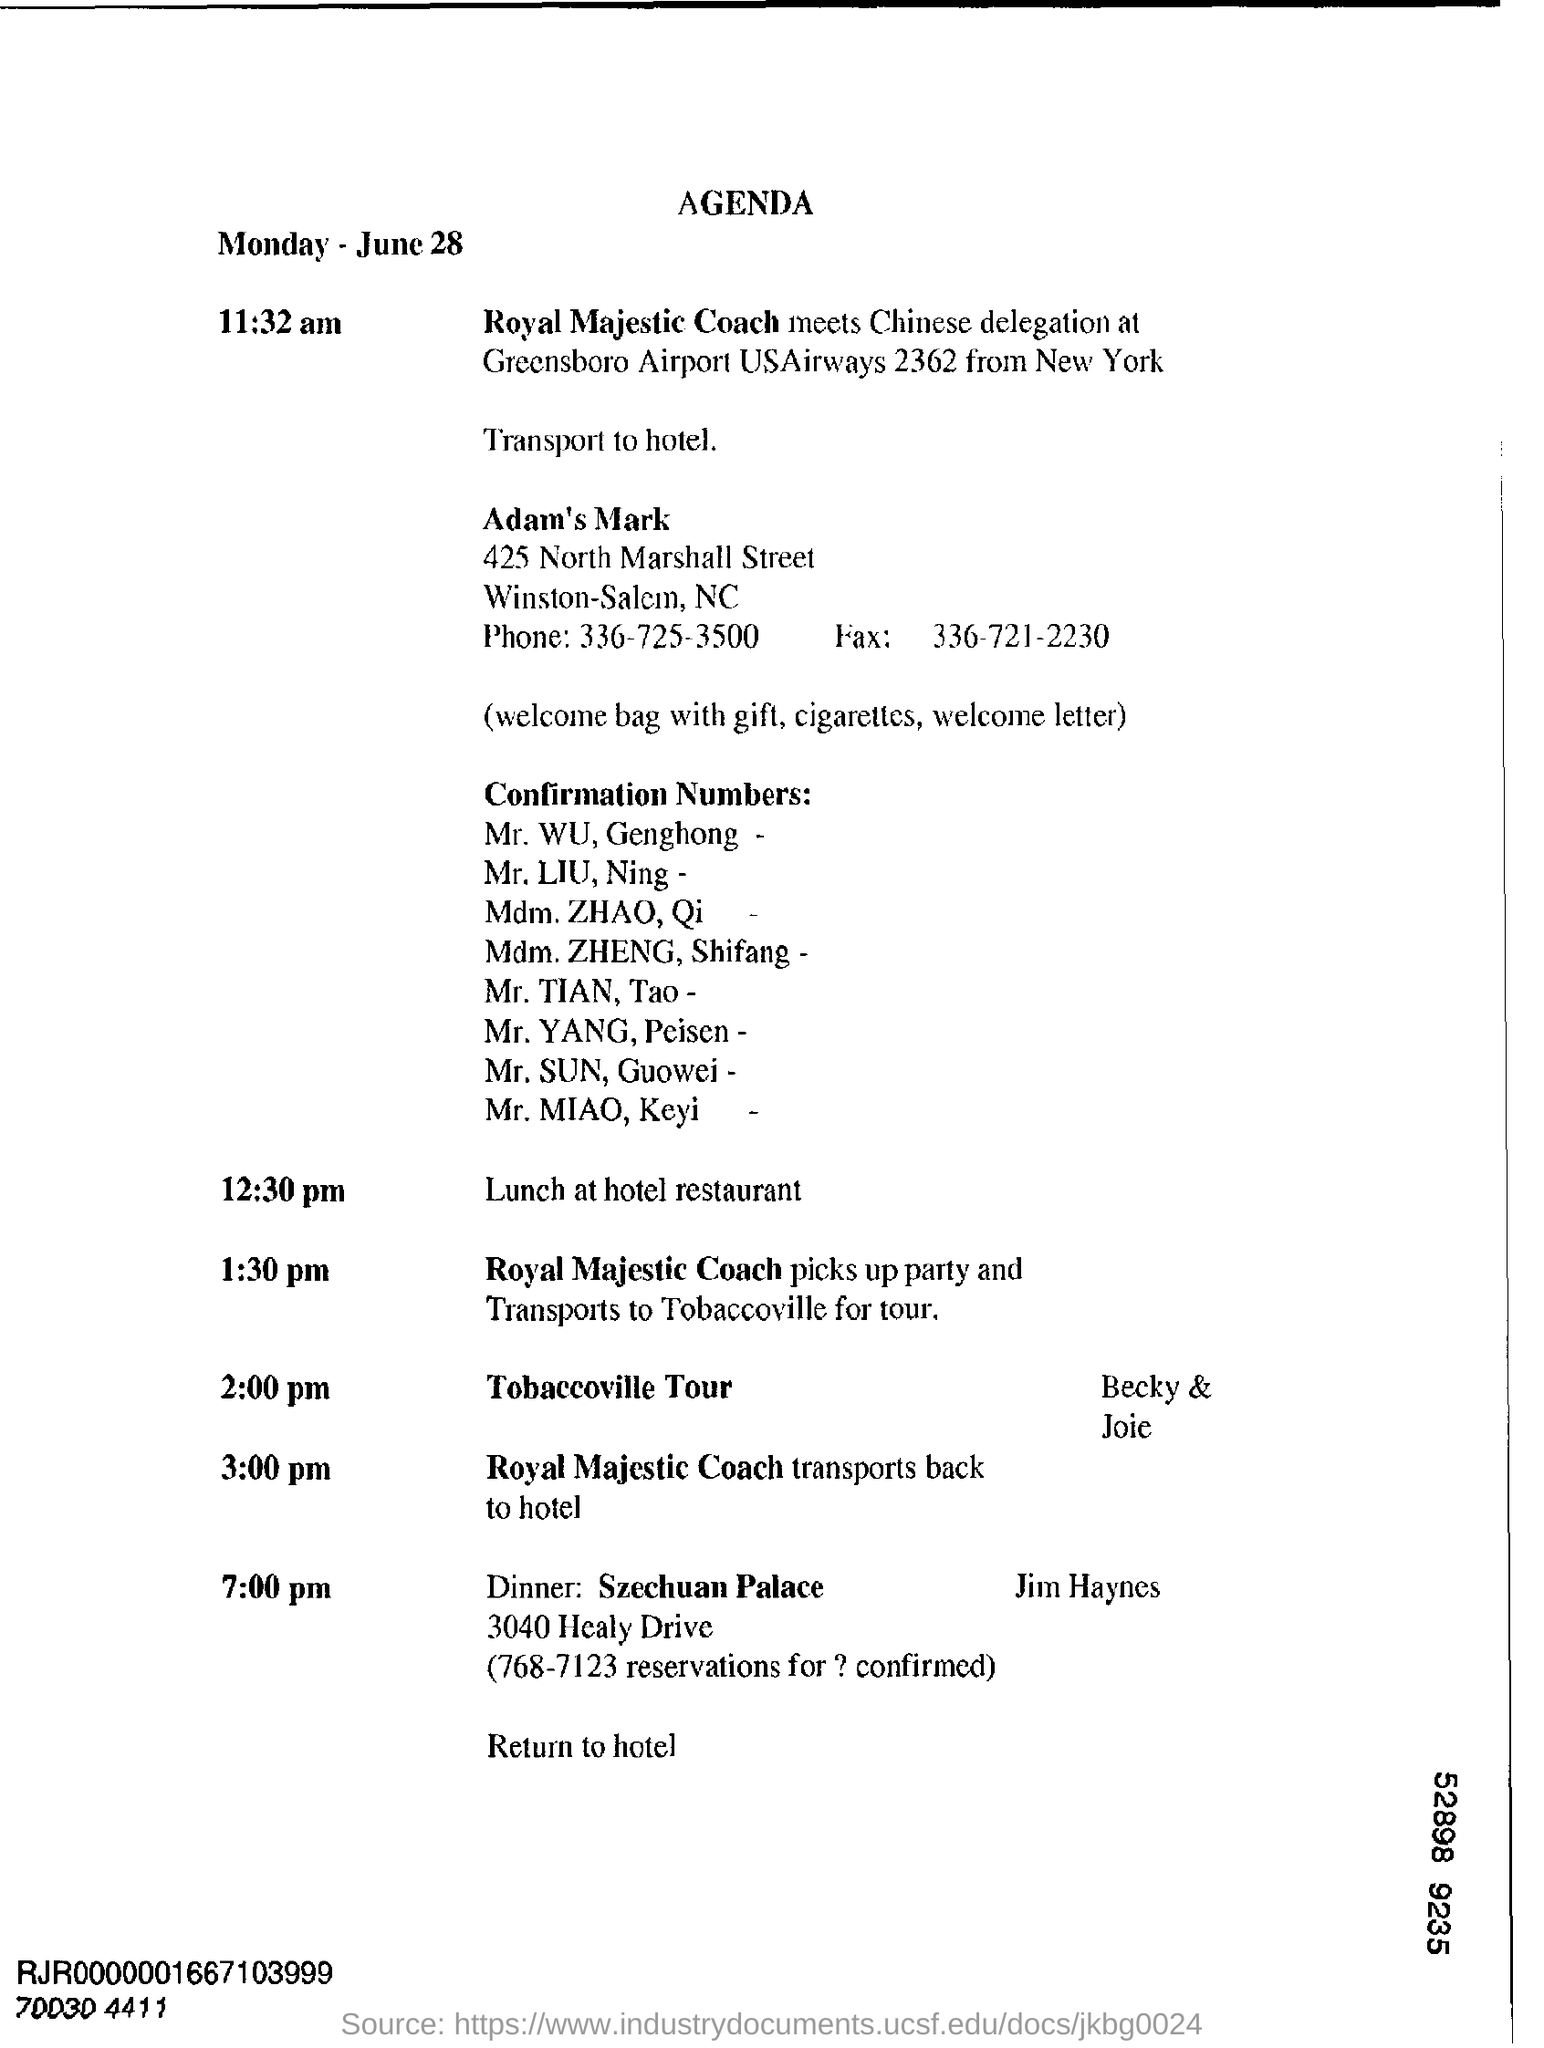Highlight a few significant elements in this photo. What is the fax number? It is 336-721-2230. The phone number is 336-725-3500. The title of the document is Agenda. The date mentioned at the top of the document is June 28. 